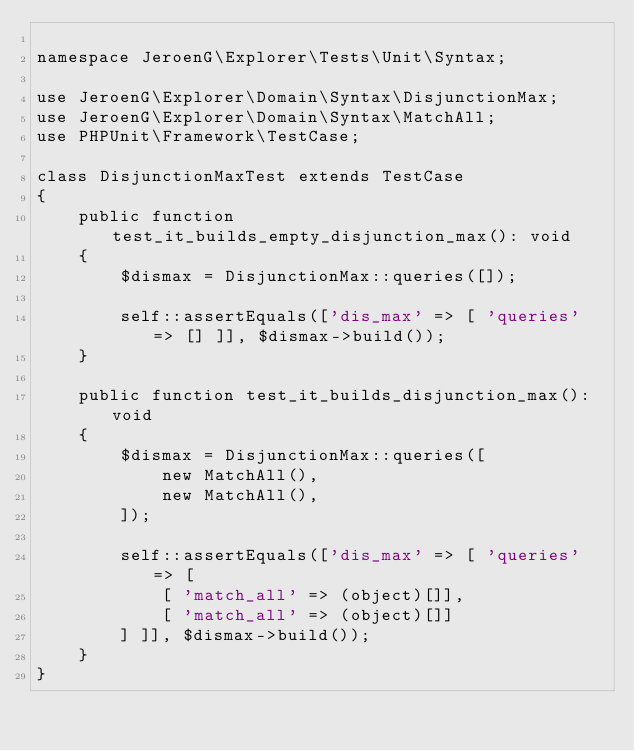Convert code to text. <code><loc_0><loc_0><loc_500><loc_500><_PHP_>
namespace JeroenG\Explorer\Tests\Unit\Syntax;

use JeroenG\Explorer\Domain\Syntax\DisjunctionMax;
use JeroenG\Explorer\Domain\Syntax\MatchAll;
use PHPUnit\Framework\TestCase;

class DisjunctionMaxTest extends TestCase
{
    public function test_it_builds_empty_disjunction_max(): void
    {
        $dismax = DisjunctionMax::queries([]);

        self::assertEquals(['dis_max' => [ 'queries' => [] ]], $dismax->build());
    }

    public function test_it_builds_disjunction_max(): void
    {
        $dismax = DisjunctionMax::queries([
            new MatchAll(),
            new MatchAll(),
        ]);

        self::assertEquals(['dis_max' => [ 'queries' => [
            [ 'match_all' => (object)[]],
            [ 'match_all' => (object)[]]
        ] ]], $dismax->build());
    }
}
</code> 